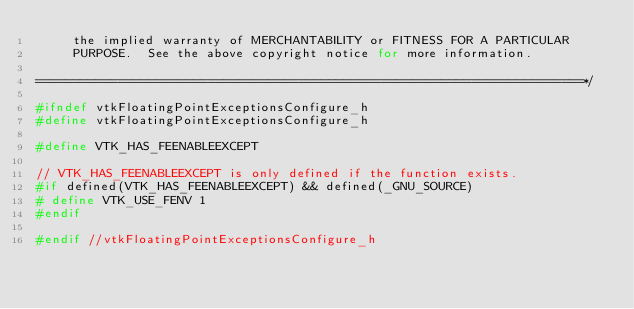<code> <loc_0><loc_0><loc_500><loc_500><_C_>     the implied warranty of MERCHANTABILITY or FITNESS FOR A PARTICULAR
     PURPOSE.  See the above copyright notice for more information.

=========================================================================*/

#ifndef vtkFloatingPointExceptionsConfigure_h
#define vtkFloatingPointExceptionsConfigure_h

#define VTK_HAS_FEENABLEEXCEPT

// VTK_HAS_FEENABLEEXCEPT is only defined if the function exists.
#if defined(VTK_HAS_FEENABLEEXCEPT) && defined(_GNU_SOURCE)
# define VTK_USE_FENV 1
#endif

#endif //vtkFloatingPointExceptionsConfigure_h
</code> 